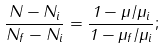Convert formula to latex. <formula><loc_0><loc_0><loc_500><loc_500>\frac { N - N _ { i } } { N _ { f } - N _ { i } } = \frac { 1 - \mu / \mu _ { i } } { 1 - \mu _ { f } / \mu _ { i } } ;</formula> 